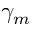Convert formula to latex. <formula><loc_0><loc_0><loc_500><loc_500>\gamma _ { m }</formula> 